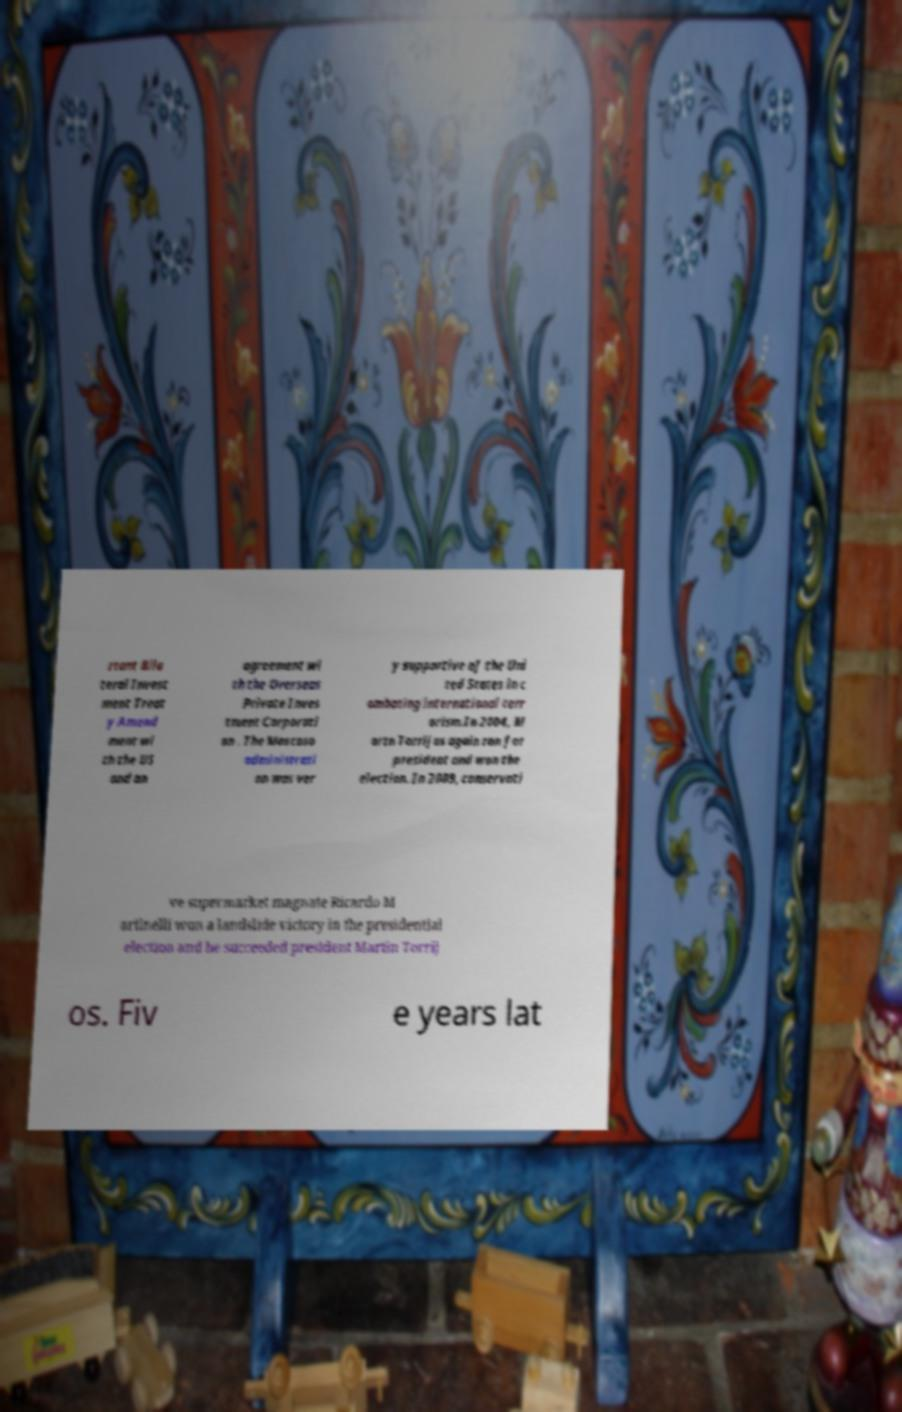There's text embedded in this image that I need extracted. Can you transcribe it verbatim? rtant Bila teral Invest ment Treat y Amend ment wi th the US and an agreement wi th the Overseas Private Inves tment Corporati on . The Moscoso administrati on was ver y supportive of the Uni ted States in c ombating international terr orism.In 2004, M artn Torrijos again ran for president and won the election. In 2009, conservati ve supermarket magnate Ricardo M artinelli won a landslide victory in the presidential election and he succeeded president Martin Torrij os. Fiv e years lat 